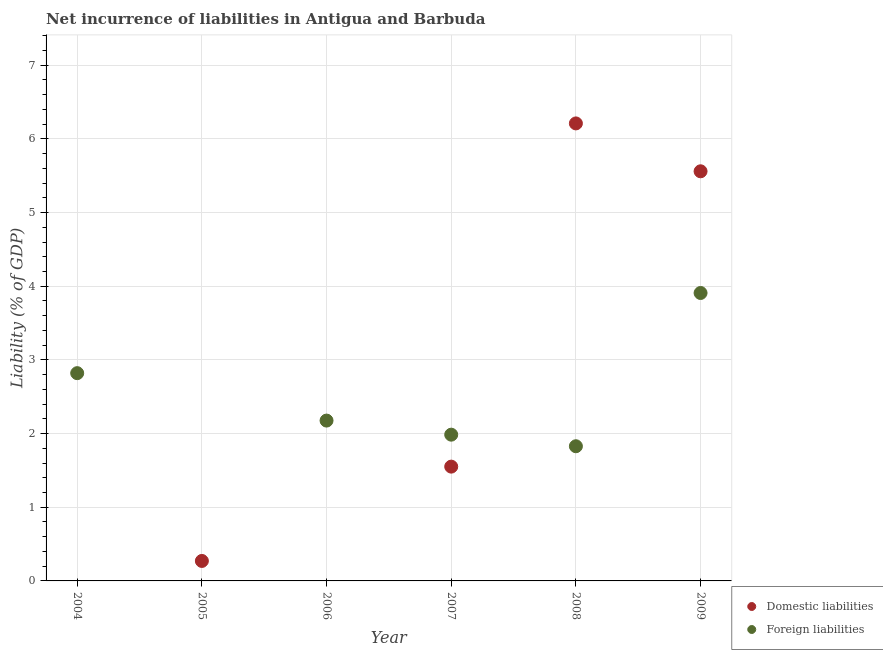How many different coloured dotlines are there?
Your answer should be very brief. 2. Is the number of dotlines equal to the number of legend labels?
Provide a succinct answer. No. What is the incurrence of foreign liabilities in 2008?
Ensure brevity in your answer.  1.83. Across all years, what is the maximum incurrence of foreign liabilities?
Make the answer very short. 3.91. Across all years, what is the minimum incurrence of domestic liabilities?
Give a very brief answer. 0. What is the total incurrence of domestic liabilities in the graph?
Your response must be concise. 13.59. What is the difference between the incurrence of foreign liabilities in 2004 and that in 2008?
Keep it short and to the point. 0.99. What is the difference between the incurrence of foreign liabilities in 2007 and the incurrence of domestic liabilities in 2005?
Keep it short and to the point. 1.71. What is the average incurrence of foreign liabilities per year?
Keep it short and to the point. 2.12. In the year 2009, what is the difference between the incurrence of foreign liabilities and incurrence of domestic liabilities?
Your response must be concise. -1.65. In how many years, is the incurrence of domestic liabilities greater than 6.6 %?
Provide a succinct answer. 0. What is the ratio of the incurrence of foreign liabilities in 2006 to that in 2007?
Ensure brevity in your answer.  1.1. Is the incurrence of foreign liabilities in 2006 less than that in 2007?
Your answer should be very brief. No. What is the difference between the highest and the second highest incurrence of foreign liabilities?
Provide a short and direct response. 1.09. What is the difference between the highest and the lowest incurrence of foreign liabilities?
Keep it short and to the point. 3.91. In how many years, is the incurrence of domestic liabilities greater than the average incurrence of domestic liabilities taken over all years?
Keep it short and to the point. 2. Is the incurrence of domestic liabilities strictly greater than the incurrence of foreign liabilities over the years?
Your answer should be very brief. No. How many years are there in the graph?
Your response must be concise. 6. What is the difference between two consecutive major ticks on the Y-axis?
Give a very brief answer. 1. Are the values on the major ticks of Y-axis written in scientific E-notation?
Give a very brief answer. No. Does the graph contain any zero values?
Provide a short and direct response. Yes. Does the graph contain grids?
Keep it short and to the point. Yes. What is the title of the graph?
Provide a succinct answer. Net incurrence of liabilities in Antigua and Barbuda. Does "Fixed telephone" appear as one of the legend labels in the graph?
Provide a succinct answer. No. What is the label or title of the Y-axis?
Provide a succinct answer. Liability (% of GDP). What is the Liability (% of GDP) in Domestic liabilities in 2004?
Make the answer very short. 0. What is the Liability (% of GDP) of Foreign liabilities in 2004?
Keep it short and to the point. 2.82. What is the Liability (% of GDP) in Domestic liabilities in 2005?
Give a very brief answer. 0.27. What is the Liability (% of GDP) of Domestic liabilities in 2006?
Give a very brief answer. 0. What is the Liability (% of GDP) in Foreign liabilities in 2006?
Offer a terse response. 2.18. What is the Liability (% of GDP) in Domestic liabilities in 2007?
Keep it short and to the point. 1.55. What is the Liability (% of GDP) in Foreign liabilities in 2007?
Your answer should be very brief. 1.99. What is the Liability (% of GDP) of Domestic liabilities in 2008?
Provide a short and direct response. 6.21. What is the Liability (% of GDP) of Foreign liabilities in 2008?
Offer a terse response. 1.83. What is the Liability (% of GDP) of Domestic liabilities in 2009?
Offer a very short reply. 5.56. What is the Liability (% of GDP) in Foreign liabilities in 2009?
Your answer should be compact. 3.91. Across all years, what is the maximum Liability (% of GDP) in Domestic liabilities?
Your answer should be very brief. 6.21. Across all years, what is the maximum Liability (% of GDP) of Foreign liabilities?
Ensure brevity in your answer.  3.91. Across all years, what is the minimum Liability (% of GDP) in Domestic liabilities?
Keep it short and to the point. 0. Across all years, what is the minimum Liability (% of GDP) of Foreign liabilities?
Provide a succinct answer. 0. What is the total Liability (% of GDP) in Domestic liabilities in the graph?
Your answer should be very brief. 13.59. What is the total Liability (% of GDP) of Foreign liabilities in the graph?
Offer a very short reply. 12.72. What is the difference between the Liability (% of GDP) of Foreign liabilities in 2004 and that in 2006?
Offer a very short reply. 0.64. What is the difference between the Liability (% of GDP) of Foreign liabilities in 2004 and that in 2007?
Keep it short and to the point. 0.83. What is the difference between the Liability (% of GDP) of Foreign liabilities in 2004 and that in 2008?
Ensure brevity in your answer.  0.99. What is the difference between the Liability (% of GDP) in Foreign liabilities in 2004 and that in 2009?
Offer a very short reply. -1.09. What is the difference between the Liability (% of GDP) in Domestic liabilities in 2005 and that in 2007?
Provide a succinct answer. -1.28. What is the difference between the Liability (% of GDP) of Domestic liabilities in 2005 and that in 2008?
Offer a terse response. -5.94. What is the difference between the Liability (% of GDP) of Domestic liabilities in 2005 and that in 2009?
Offer a very short reply. -5.29. What is the difference between the Liability (% of GDP) in Foreign liabilities in 2006 and that in 2007?
Provide a short and direct response. 0.19. What is the difference between the Liability (% of GDP) of Foreign liabilities in 2006 and that in 2008?
Make the answer very short. 0.35. What is the difference between the Liability (% of GDP) in Foreign liabilities in 2006 and that in 2009?
Your answer should be very brief. -1.73. What is the difference between the Liability (% of GDP) of Domestic liabilities in 2007 and that in 2008?
Provide a short and direct response. -4.66. What is the difference between the Liability (% of GDP) in Foreign liabilities in 2007 and that in 2008?
Give a very brief answer. 0.16. What is the difference between the Liability (% of GDP) in Domestic liabilities in 2007 and that in 2009?
Provide a short and direct response. -4.01. What is the difference between the Liability (% of GDP) of Foreign liabilities in 2007 and that in 2009?
Your response must be concise. -1.92. What is the difference between the Liability (% of GDP) of Domestic liabilities in 2008 and that in 2009?
Offer a terse response. 0.65. What is the difference between the Liability (% of GDP) in Foreign liabilities in 2008 and that in 2009?
Give a very brief answer. -2.08. What is the difference between the Liability (% of GDP) in Domestic liabilities in 2005 and the Liability (% of GDP) in Foreign liabilities in 2006?
Keep it short and to the point. -1.91. What is the difference between the Liability (% of GDP) of Domestic liabilities in 2005 and the Liability (% of GDP) of Foreign liabilities in 2007?
Offer a terse response. -1.71. What is the difference between the Liability (% of GDP) in Domestic liabilities in 2005 and the Liability (% of GDP) in Foreign liabilities in 2008?
Provide a short and direct response. -1.56. What is the difference between the Liability (% of GDP) in Domestic liabilities in 2005 and the Liability (% of GDP) in Foreign liabilities in 2009?
Provide a succinct answer. -3.64. What is the difference between the Liability (% of GDP) of Domestic liabilities in 2007 and the Liability (% of GDP) of Foreign liabilities in 2008?
Your response must be concise. -0.28. What is the difference between the Liability (% of GDP) in Domestic liabilities in 2007 and the Liability (% of GDP) in Foreign liabilities in 2009?
Keep it short and to the point. -2.36. What is the difference between the Liability (% of GDP) of Domestic liabilities in 2008 and the Liability (% of GDP) of Foreign liabilities in 2009?
Offer a very short reply. 2.3. What is the average Liability (% of GDP) of Domestic liabilities per year?
Your answer should be compact. 2.27. What is the average Liability (% of GDP) of Foreign liabilities per year?
Keep it short and to the point. 2.12. In the year 2007, what is the difference between the Liability (% of GDP) in Domestic liabilities and Liability (% of GDP) in Foreign liabilities?
Your answer should be compact. -0.43. In the year 2008, what is the difference between the Liability (% of GDP) in Domestic liabilities and Liability (% of GDP) in Foreign liabilities?
Provide a short and direct response. 4.38. In the year 2009, what is the difference between the Liability (% of GDP) in Domestic liabilities and Liability (% of GDP) in Foreign liabilities?
Offer a terse response. 1.65. What is the ratio of the Liability (% of GDP) in Foreign liabilities in 2004 to that in 2006?
Provide a succinct answer. 1.3. What is the ratio of the Liability (% of GDP) of Foreign liabilities in 2004 to that in 2007?
Ensure brevity in your answer.  1.42. What is the ratio of the Liability (% of GDP) of Foreign liabilities in 2004 to that in 2008?
Keep it short and to the point. 1.54. What is the ratio of the Liability (% of GDP) of Foreign liabilities in 2004 to that in 2009?
Provide a short and direct response. 0.72. What is the ratio of the Liability (% of GDP) in Domestic liabilities in 2005 to that in 2007?
Your answer should be compact. 0.17. What is the ratio of the Liability (% of GDP) in Domestic liabilities in 2005 to that in 2008?
Your answer should be very brief. 0.04. What is the ratio of the Liability (% of GDP) of Domestic liabilities in 2005 to that in 2009?
Offer a very short reply. 0.05. What is the ratio of the Liability (% of GDP) of Foreign liabilities in 2006 to that in 2007?
Ensure brevity in your answer.  1.1. What is the ratio of the Liability (% of GDP) of Foreign liabilities in 2006 to that in 2008?
Provide a succinct answer. 1.19. What is the ratio of the Liability (% of GDP) in Foreign liabilities in 2006 to that in 2009?
Your answer should be compact. 0.56. What is the ratio of the Liability (% of GDP) of Domestic liabilities in 2007 to that in 2008?
Offer a very short reply. 0.25. What is the ratio of the Liability (% of GDP) of Foreign liabilities in 2007 to that in 2008?
Make the answer very short. 1.09. What is the ratio of the Liability (% of GDP) of Domestic liabilities in 2007 to that in 2009?
Your answer should be very brief. 0.28. What is the ratio of the Liability (% of GDP) in Foreign liabilities in 2007 to that in 2009?
Offer a terse response. 0.51. What is the ratio of the Liability (% of GDP) in Domestic liabilities in 2008 to that in 2009?
Offer a very short reply. 1.12. What is the ratio of the Liability (% of GDP) of Foreign liabilities in 2008 to that in 2009?
Offer a terse response. 0.47. What is the difference between the highest and the second highest Liability (% of GDP) in Domestic liabilities?
Offer a terse response. 0.65. What is the difference between the highest and the second highest Liability (% of GDP) of Foreign liabilities?
Your response must be concise. 1.09. What is the difference between the highest and the lowest Liability (% of GDP) in Domestic liabilities?
Provide a short and direct response. 6.21. What is the difference between the highest and the lowest Liability (% of GDP) of Foreign liabilities?
Your answer should be very brief. 3.91. 